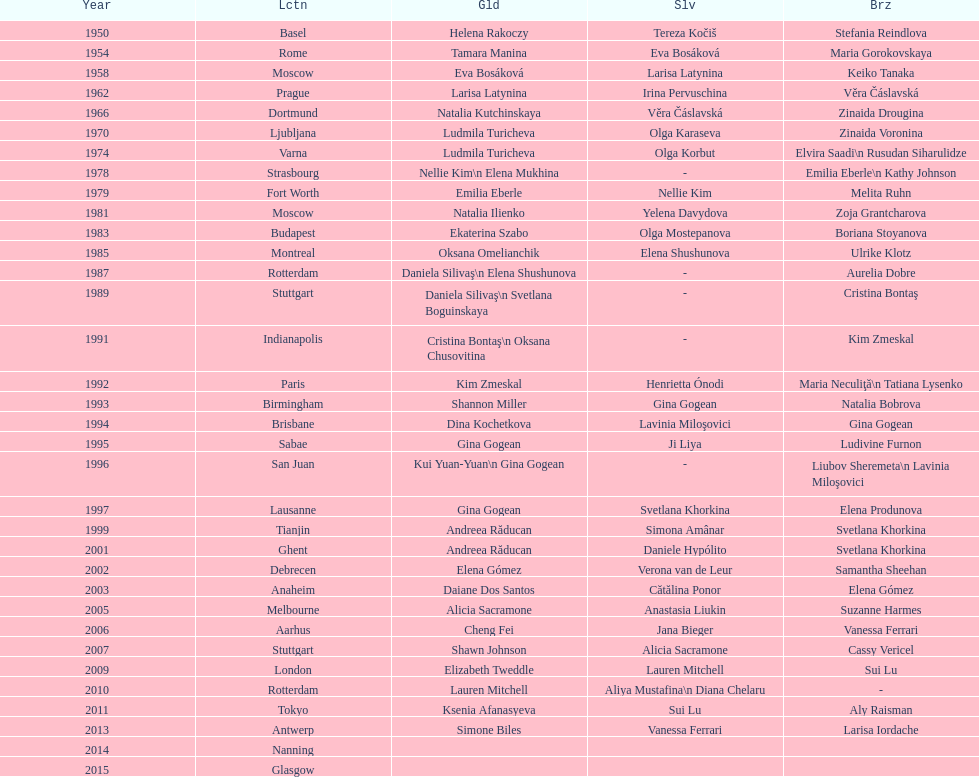What is the total number of russian gymnasts that have won silver. 8. Would you mind parsing the complete table? {'header': ['Year', 'Lctn', 'Gld', 'Slv', 'Brz'], 'rows': [['1950', 'Basel', 'Helena Rakoczy', 'Tereza Kočiš', 'Stefania Reindlova'], ['1954', 'Rome', 'Tamara Manina', 'Eva Bosáková', 'Maria Gorokovskaya'], ['1958', 'Moscow', 'Eva Bosáková', 'Larisa Latynina', 'Keiko Tanaka'], ['1962', 'Prague', 'Larisa Latynina', 'Irina Pervuschina', 'Věra Čáslavská'], ['1966', 'Dortmund', 'Natalia Kutchinskaya', 'Věra Čáslavská', 'Zinaida Drougina'], ['1970', 'Ljubljana', 'Ludmila Turicheva', 'Olga Karaseva', 'Zinaida Voronina'], ['1974', 'Varna', 'Ludmila Turicheva', 'Olga Korbut', 'Elvira Saadi\\n Rusudan Siharulidze'], ['1978', 'Strasbourg', 'Nellie Kim\\n Elena Mukhina', '-', 'Emilia Eberle\\n Kathy Johnson'], ['1979', 'Fort Worth', 'Emilia Eberle', 'Nellie Kim', 'Melita Ruhn'], ['1981', 'Moscow', 'Natalia Ilienko', 'Yelena Davydova', 'Zoja Grantcharova'], ['1983', 'Budapest', 'Ekaterina Szabo', 'Olga Mostepanova', 'Boriana Stoyanova'], ['1985', 'Montreal', 'Oksana Omelianchik', 'Elena Shushunova', 'Ulrike Klotz'], ['1987', 'Rotterdam', 'Daniela Silivaş\\n Elena Shushunova', '-', 'Aurelia Dobre'], ['1989', 'Stuttgart', 'Daniela Silivaş\\n Svetlana Boguinskaya', '-', 'Cristina Bontaş'], ['1991', 'Indianapolis', 'Cristina Bontaş\\n Oksana Chusovitina', '-', 'Kim Zmeskal'], ['1992', 'Paris', 'Kim Zmeskal', 'Henrietta Ónodi', 'Maria Neculiţă\\n Tatiana Lysenko'], ['1993', 'Birmingham', 'Shannon Miller', 'Gina Gogean', 'Natalia Bobrova'], ['1994', 'Brisbane', 'Dina Kochetkova', 'Lavinia Miloşovici', 'Gina Gogean'], ['1995', 'Sabae', 'Gina Gogean', 'Ji Liya', 'Ludivine Furnon'], ['1996', 'San Juan', 'Kui Yuan-Yuan\\n Gina Gogean', '-', 'Liubov Sheremeta\\n Lavinia Miloşovici'], ['1997', 'Lausanne', 'Gina Gogean', 'Svetlana Khorkina', 'Elena Produnova'], ['1999', 'Tianjin', 'Andreea Răducan', 'Simona Amânar', 'Svetlana Khorkina'], ['2001', 'Ghent', 'Andreea Răducan', 'Daniele Hypólito', 'Svetlana Khorkina'], ['2002', 'Debrecen', 'Elena Gómez', 'Verona van de Leur', 'Samantha Sheehan'], ['2003', 'Anaheim', 'Daiane Dos Santos', 'Cătălina Ponor', 'Elena Gómez'], ['2005', 'Melbourne', 'Alicia Sacramone', 'Anastasia Liukin', 'Suzanne Harmes'], ['2006', 'Aarhus', 'Cheng Fei', 'Jana Bieger', 'Vanessa Ferrari'], ['2007', 'Stuttgart', 'Shawn Johnson', 'Alicia Sacramone', 'Cassy Vericel'], ['2009', 'London', 'Elizabeth Tweddle', 'Lauren Mitchell', 'Sui Lu'], ['2010', 'Rotterdam', 'Lauren Mitchell', 'Aliya Mustafina\\n Diana Chelaru', '-'], ['2011', 'Tokyo', 'Ksenia Afanasyeva', 'Sui Lu', 'Aly Raisman'], ['2013', 'Antwerp', 'Simone Biles', 'Vanessa Ferrari', 'Larisa Iordache'], ['2014', 'Nanning', '', '', ''], ['2015', 'Glasgow', '', '', '']]} 